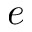<formula> <loc_0><loc_0><loc_500><loc_500>e</formula> 